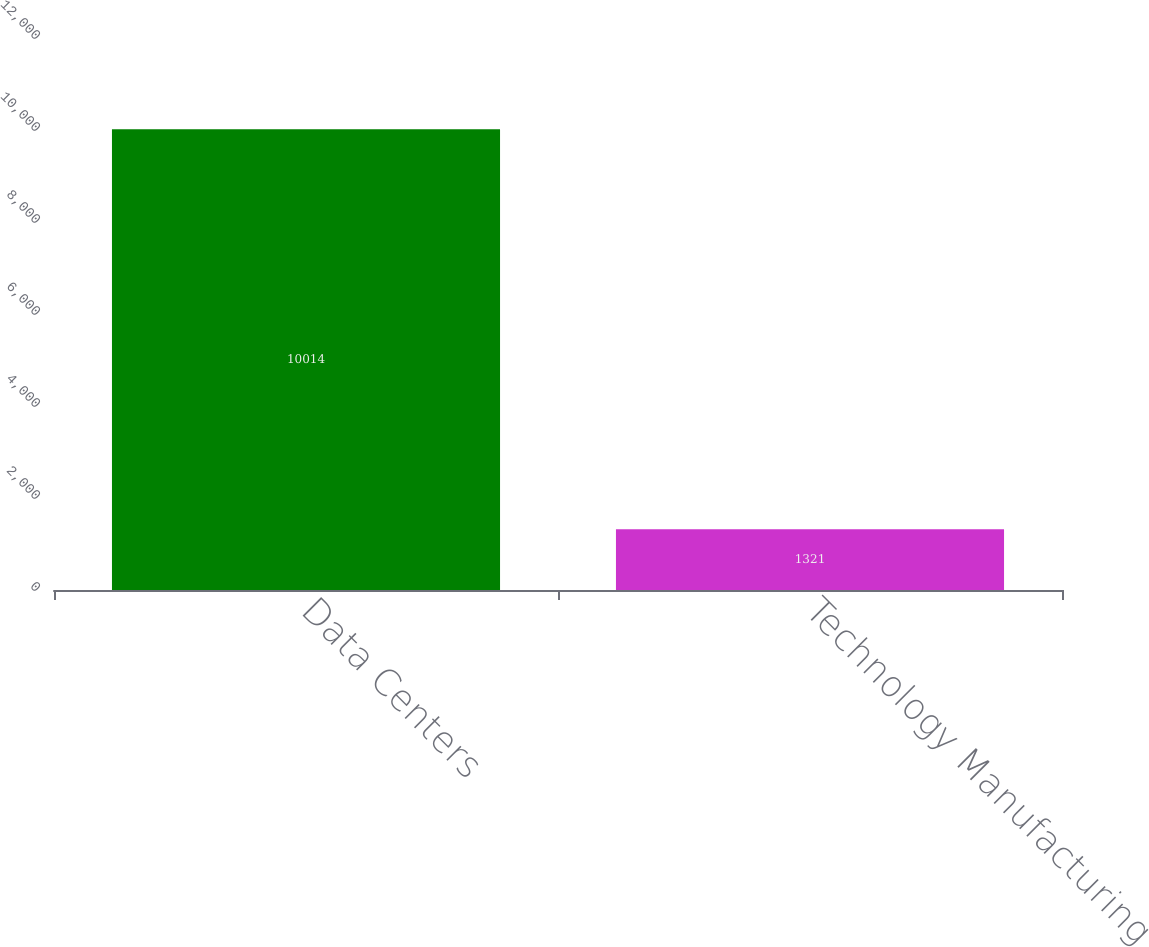<chart> <loc_0><loc_0><loc_500><loc_500><bar_chart><fcel>Data Centers<fcel>Technology Manufacturing<nl><fcel>10014<fcel>1321<nl></chart> 